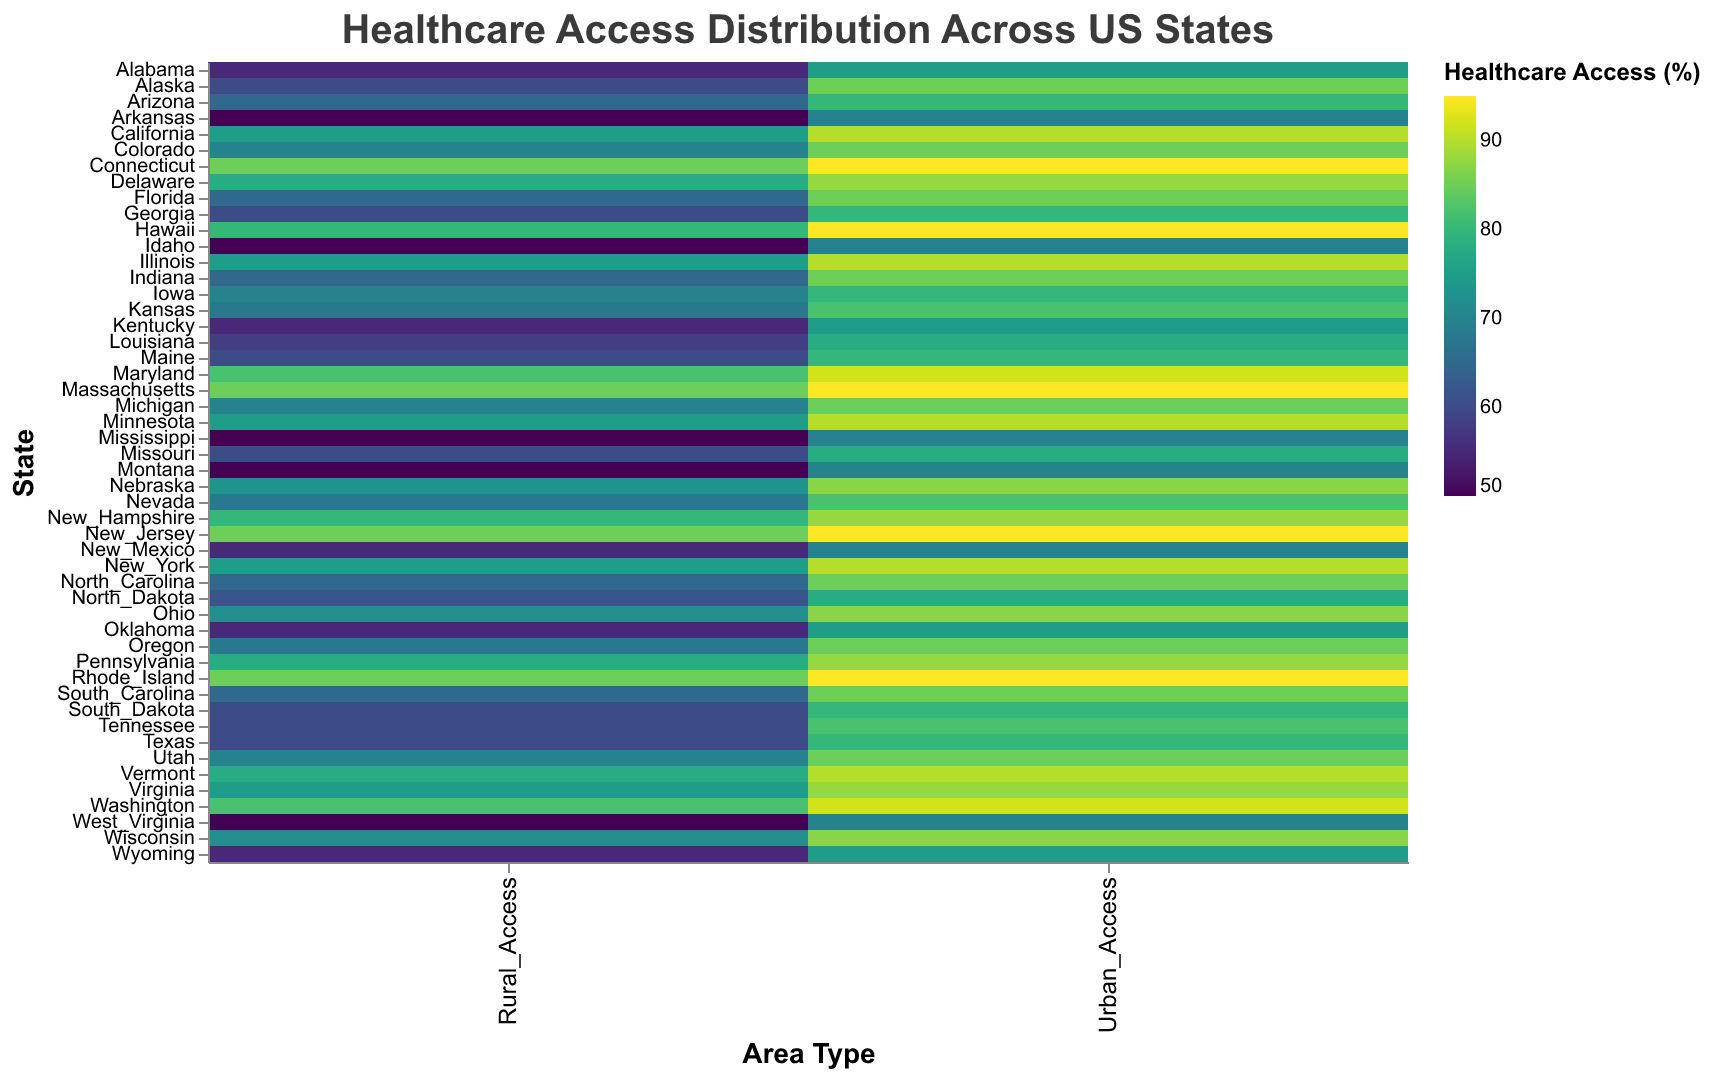What is the title of the heatmap? The title of the heatmap is usually displayed prominently at the top of the chart. Here, it reads "Healthcare Access Distribution Across US States."
Answer: Healthcare Access Distribution Across US States How many states have both urban and rural healthcare access values? By counting the number of distinct states mentioned in the y-axis, we can determine that data for 50 states is presented, each with urban and rural healthcare access values.
Answer: 50 Which state has the highest urban healthcare access percentage? Looking for the highest value in the "Urban_Access" column, we find that multiple states have an urban healthcare access value of 95%, including Connecticut, Massachusetts, New Jersey, and Rhode Island.
Answer: Connecticut, Massachusetts, New Jersey, Rhode Island What is the difference in healthcare access between urban and rural areas for California? By subtracting the rural value from the urban value for California: 90 (Urban_Access) - 75 (Rural_Access) = 15.
Answer: 15 Which state shows the least access in rural areas? The minimum value in the "Rural_Access" column is 50. States like Arkansas, Idaho, Mississippi, Montana, and West Virginia all have this value.
Answer: Arkansas, Idaho, Mississippi, Montana, West Virginia How does urban healthcare access in Texas compare to urban healthcare access in Florida? Comparing the values from the "Urban_Access" column for Texas (80) and Florida (85), Florida has higher access.
Answer: Florida has higher urban healthcare access than Texas What is the average healthcare access percentage for rural areas across all states? Adding up all the rural access values and dividing by the number of states (50): (55 + 60 + 65 + ... + 55) / 50 = 65.2
Answer: 65.2 Which state has the highest difference between urban and rural healthcare access? By calculating the differences for all states and finding the maximum value, Connecticut has the highest difference: 95 (Urban_Access) - 85 (Rural_Access) = 10.
Answer: Connecticut Are there any states where urban and rural healthcare access percentages are equal? By examining the differences between Urban_Access and Rural_Access values for each state, no states have equal values.
Answer: No What is the overall trend in healthcare access between urban and rural areas across the states? Typically, urban areas demonstrate higher access percentages than rural areas, indicating a disparity in healthcare access favoring urban regions.
Answer: Urban areas have higher access than rural areas 